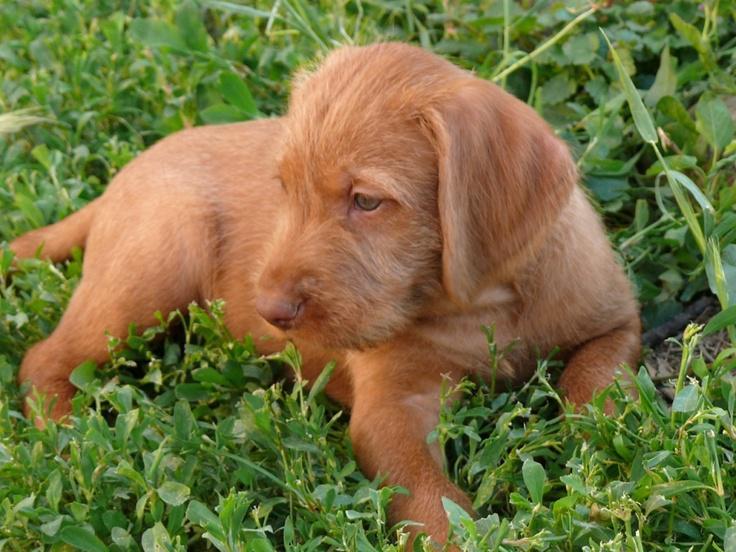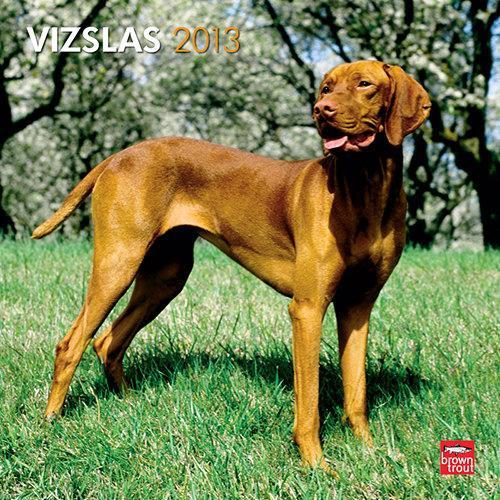The first image is the image on the left, the second image is the image on the right. Examine the images to the left and right. Is the description "There are two adult dogs" accurate? Answer yes or no. No. The first image is the image on the left, the second image is the image on the right. For the images displayed, is the sentence "At least one of the dogs is carrying something in its mouth." factually correct? Answer yes or no. No. 